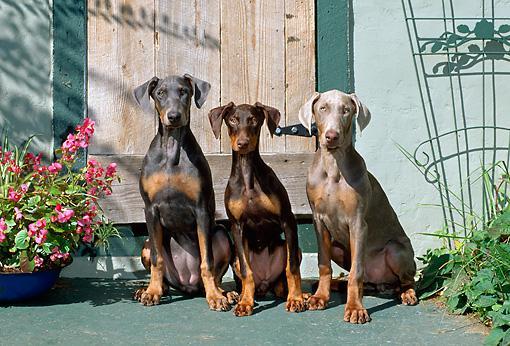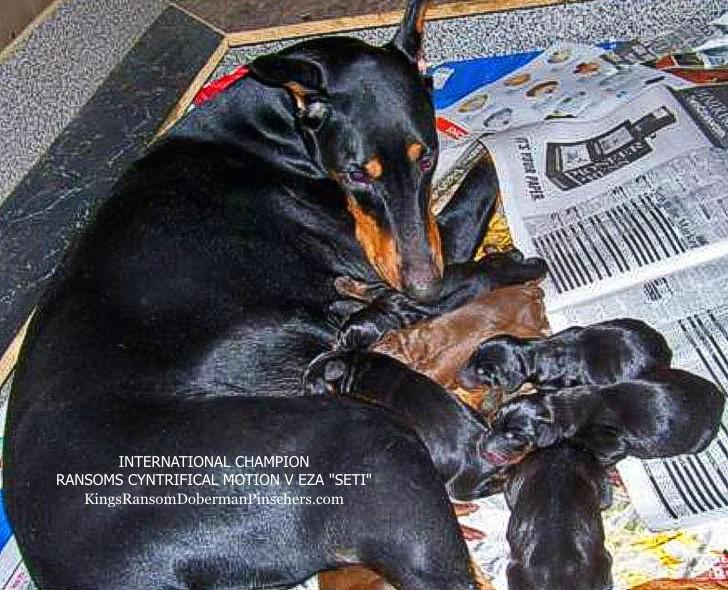The first image is the image on the left, the second image is the image on the right. Given the left and right images, does the statement "The right image contains exactly three doberman dogs with erect pointy ears wearing leashes and collars." hold true? Answer yes or no. No. The first image is the image on the left, the second image is the image on the right. For the images displayed, is the sentence "There are three dogs sitting down." factually correct? Answer yes or no. Yes. 